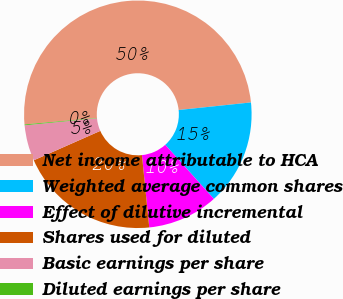<chart> <loc_0><loc_0><loc_500><loc_500><pie_chart><fcel>Net income attributable to HCA<fcel>Weighted average common shares<fcel>Effect of dilutive incremental<fcel>Shares used for diluted<fcel>Basic earnings per share<fcel>Diluted earnings per share<nl><fcel>49.77%<fcel>15.01%<fcel>10.05%<fcel>19.98%<fcel>5.08%<fcel>0.12%<nl></chart> 